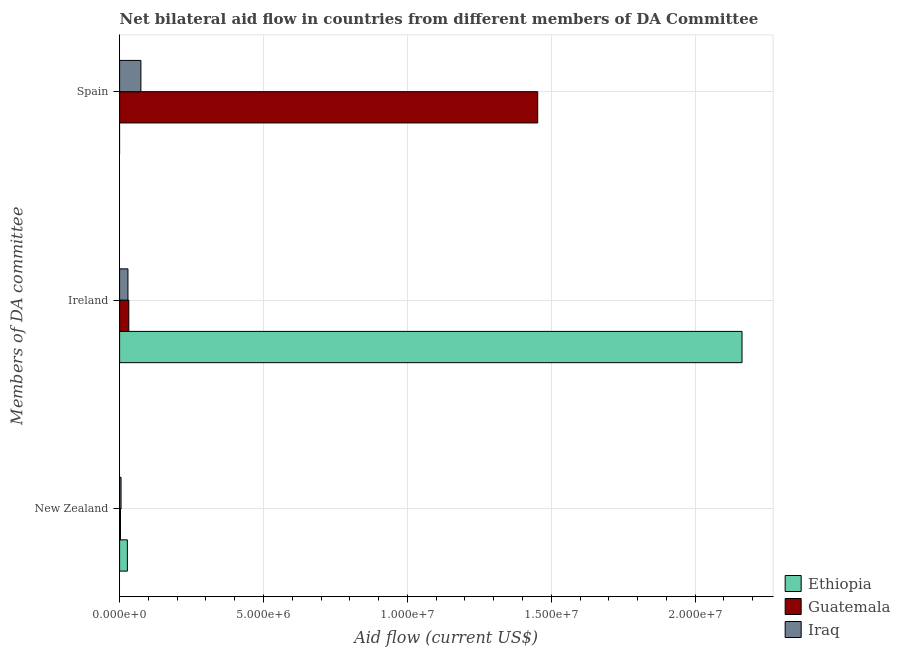Are the number of bars per tick equal to the number of legend labels?
Keep it short and to the point. No. Are the number of bars on each tick of the Y-axis equal?
Provide a succinct answer. No. How many bars are there on the 1st tick from the top?
Provide a succinct answer. 2. How many bars are there on the 2nd tick from the bottom?
Provide a short and direct response. 3. What is the label of the 3rd group of bars from the top?
Give a very brief answer. New Zealand. What is the amount of aid provided by spain in Ethiopia?
Give a very brief answer. 0. Across all countries, what is the maximum amount of aid provided by spain?
Offer a very short reply. 1.45e+07. Across all countries, what is the minimum amount of aid provided by new zealand?
Ensure brevity in your answer.  3.00e+04. In which country was the amount of aid provided by ireland maximum?
Offer a very short reply. Ethiopia. What is the total amount of aid provided by spain in the graph?
Provide a short and direct response. 1.53e+07. What is the difference between the amount of aid provided by ireland in Ethiopia and that in Iraq?
Your response must be concise. 2.13e+07. What is the difference between the amount of aid provided by ireland in Iraq and the amount of aid provided by spain in Ethiopia?
Your answer should be compact. 2.90e+05. What is the average amount of aid provided by spain per country?
Ensure brevity in your answer.  5.09e+06. What is the difference between the amount of aid provided by spain and amount of aid provided by new zealand in Guatemala?
Offer a very short reply. 1.45e+07. What is the difference between the highest and the second highest amount of aid provided by new zealand?
Your response must be concise. 2.20e+05. What is the difference between the highest and the lowest amount of aid provided by ireland?
Provide a succinct answer. 2.13e+07. Are all the bars in the graph horizontal?
Provide a succinct answer. Yes. Does the graph contain any zero values?
Your response must be concise. Yes. Does the graph contain grids?
Your answer should be compact. Yes. Where does the legend appear in the graph?
Provide a succinct answer. Bottom right. How are the legend labels stacked?
Your response must be concise. Vertical. What is the title of the graph?
Keep it short and to the point. Net bilateral aid flow in countries from different members of DA Committee. Does "St. Vincent and the Grenadines" appear as one of the legend labels in the graph?
Make the answer very short. No. What is the label or title of the Y-axis?
Provide a succinct answer. Members of DA committee. What is the Aid flow (current US$) of Ethiopia in New Zealand?
Give a very brief answer. 2.70e+05. What is the Aid flow (current US$) of Guatemala in New Zealand?
Give a very brief answer. 3.00e+04. What is the Aid flow (current US$) of Ethiopia in Ireland?
Keep it short and to the point. 2.16e+07. What is the Aid flow (current US$) of Guatemala in Ireland?
Ensure brevity in your answer.  3.20e+05. What is the Aid flow (current US$) of Iraq in Ireland?
Your answer should be compact. 2.90e+05. What is the Aid flow (current US$) in Ethiopia in Spain?
Your answer should be compact. 0. What is the Aid flow (current US$) of Guatemala in Spain?
Your answer should be compact. 1.45e+07. What is the Aid flow (current US$) of Iraq in Spain?
Make the answer very short. 7.40e+05. Across all Members of DA committee, what is the maximum Aid flow (current US$) of Ethiopia?
Your response must be concise. 2.16e+07. Across all Members of DA committee, what is the maximum Aid flow (current US$) in Guatemala?
Offer a terse response. 1.45e+07. Across all Members of DA committee, what is the maximum Aid flow (current US$) in Iraq?
Offer a terse response. 7.40e+05. Across all Members of DA committee, what is the minimum Aid flow (current US$) in Ethiopia?
Ensure brevity in your answer.  0. Across all Members of DA committee, what is the minimum Aid flow (current US$) of Guatemala?
Provide a succinct answer. 3.00e+04. Across all Members of DA committee, what is the minimum Aid flow (current US$) in Iraq?
Make the answer very short. 5.00e+04. What is the total Aid flow (current US$) in Ethiopia in the graph?
Offer a very short reply. 2.19e+07. What is the total Aid flow (current US$) in Guatemala in the graph?
Make the answer very short. 1.49e+07. What is the total Aid flow (current US$) in Iraq in the graph?
Provide a short and direct response. 1.08e+06. What is the difference between the Aid flow (current US$) of Ethiopia in New Zealand and that in Ireland?
Provide a short and direct response. -2.14e+07. What is the difference between the Aid flow (current US$) in Guatemala in New Zealand and that in Ireland?
Your answer should be compact. -2.90e+05. What is the difference between the Aid flow (current US$) of Guatemala in New Zealand and that in Spain?
Your answer should be very brief. -1.45e+07. What is the difference between the Aid flow (current US$) of Iraq in New Zealand and that in Spain?
Ensure brevity in your answer.  -6.90e+05. What is the difference between the Aid flow (current US$) in Guatemala in Ireland and that in Spain?
Your answer should be very brief. -1.42e+07. What is the difference between the Aid flow (current US$) in Iraq in Ireland and that in Spain?
Your response must be concise. -4.50e+05. What is the difference between the Aid flow (current US$) in Ethiopia in New Zealand and the Aid flow (current US$) in Guatemala in Ireland?
Ensure brevity in your answer.  -5.00e+04. What is the difference between the Aid flow (current US$) in Ethiopia in New Zealand and the Aid flow (current US$) in Iraq in Ireland?
Give a very brief answer. -2.00e+04. What is the difference between the Aid flow (current US$) in Ethiopia in New Zealand and the Aid flow (current US$) in Guatemala in Spain?
Ensure brevity in your answer.  -1.43e+07. What is the difference between the Aid flow (current US$) of Ethiopia in New Zealand and the Aid flow (current US$) of Iraq in Spain?
Provide a succinct answer. -4.70e+05. What is the difference between the Aid flow (current US$) of Guatemala in New Zealand and the Aid flow (current US$) of Iraq in Spain?
Keep it short and to the point. -7.10e+05. What is the difference between the Aid flow (current US$) in Ethiopia in Ireland and the Aid flow (current US$) in Guatemala in Spain?
Keep it short and to the point. 7.10e+06. What is the difference between the Aid flow (current US$) in Ethiopia in Ireland and the Aid flow (current US$) in Iraq in Spain?
Keep it short and to the point. 2.09e+07. What is the difference between the Aid flow (current US$) of Guatemala in Ireland and the Aid flow (current US$) of Iraq in Spain?
Keep it short and to the point. -4.20e+05. What is the average Aid flow (current US$) of Ethiopia per Members of DA committee?
Your answer should be very brief. 7.30e+06. What is the average Aid flow (current US$) in Guatemala per Members of DA committee?
Your answer should be compact. 4.96e+06. What is the average Aid flow (current US$) in Iraq per Members of DA committee?
Your response must be concise. 3.60e+05. What is the difference between the Aid flow (current US$) in Ethiopia and Aid flow (current US$) in Guatemala in Ireland?
Keep it short and to the point. 2.13e+07. What is the difference between the Aid flow (current US$) in Ethiopia and Aid flow (current US$) in Iraq in Ireland?
Offer a terse response. 2.13e+07. What is the difference between the Aid flow (current US$) in Guatemala and Aid flow (current US$) in Iraq in Ireland?
Give a very brief answer. 3.00e+04. What is the difference between the Aid flow (current US$) of Guatemala and Aid flow (current US$) of Iraq in Spain?
Provide a succinct answer. 1.38e+07. What is the ratio of the Aid flow (current US$) in Ethiopia in New Zealand to that in Ireland?
Your answer should be compact. 0.01. What is the ratio of the Aid flow (current US$) in Guatemala in New Zealand to that in Ireland?
Make the answer very short. 0.09. What is the ratio of the Aid flow (current US$) in Iraq in New Zealand to that in Ireland?
Provide a short and direct response. 0.17. What is the ratio of the Aid flow (current US$) of Guatemala in New Zealand to that in Spain?
Offer a very short reply. 0. What is the ratio of the Aid flow (current US$) in Iraq in New Zealand to that in Spain?
Your answer should be very brief. 0.07. What is the ratio of the Aid flow (current US$) of Guatemala in Ireland to that in Spain?
Make the answer very short. 0.02. What is the ratio of the Aid flow (current US$) of Iraq in Ireland to that in Spain?
Offer a very short reply. 0.39. What is the difference between the highest and the second highest Aid flow (current US$) of Guatemala?
Ensure brevity in your answer.  1.42e+07. What is the difference between the highest and the second highest Aid flow (current US$) of Iraq?
Give a very brief answer. 4.50e+05. What is the difference between the highest and the lowest Aid flow (current US$) in Ethiopia?
Your answer should be very brief. 2.16e+07. What is the difference between the highest and the lowest Aid flow (current US$) of Guatemala?
Make the answer very short. 1.45e+07. What is the difference between the highest and the lowest Aid flow (current US$) of Iraq?
Keep it short and to the point. 6.90e+05. 